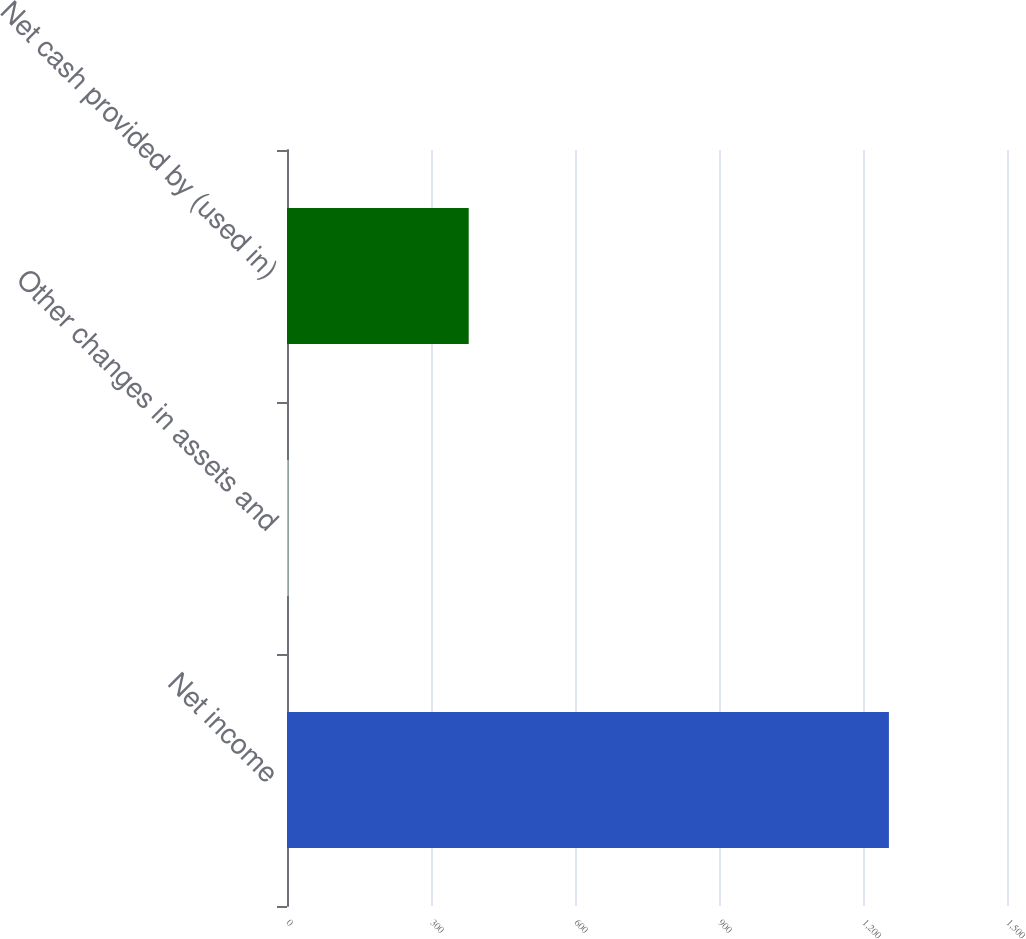<chart> <loc_0><loc_0><loc_500><loc_500><bar_chart><fcel>Net income<fcel>Other changes in assets and<fcel>Net cash provided by (used in)<nl><fcel>1254<fcel>3.4<fcel>378.58<nl></chart> 